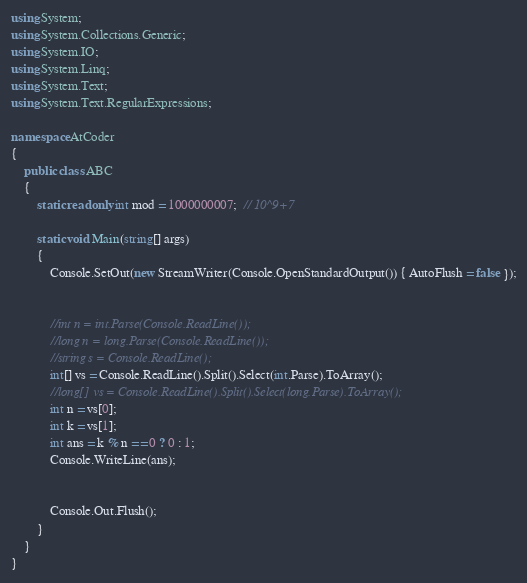<code> <loc_0><loc_0><loc_500><loc_500><_C#_>using System;
using System.Collections.Generic;
using System.IO;
using System.Linq;
using System.Text;
using System.Text.RegularExpressions;

namespace AtCoder
{
	public class ABC
	{
		static readonly int mod = 1000000007;  // 10^9+7

		static void Main(string[] args)
		{
			Console.SetOut(new StreamWriter(Console.OpenStandardOutput()) { AutoFlush = false });


			//int n = int.Parse(Console.ReadLine());
			//long n = long.Parse(Console.ReadLine());
			//string s = Console.ReadLine();
			int[] vs = Console.ReadLine().Split().Select(int.Parse).ToArray();
			//long[] vs = Console.ReadLine().Split().Select(long.Parse).ToArray();
			int n = vs[0];
			int k = vs[1];
			int ans = k % n == 0 ? 0 : 1;
			Console.WriteLine(ans);


			Console.Out.Flush();
		}
	}
}
</code> 